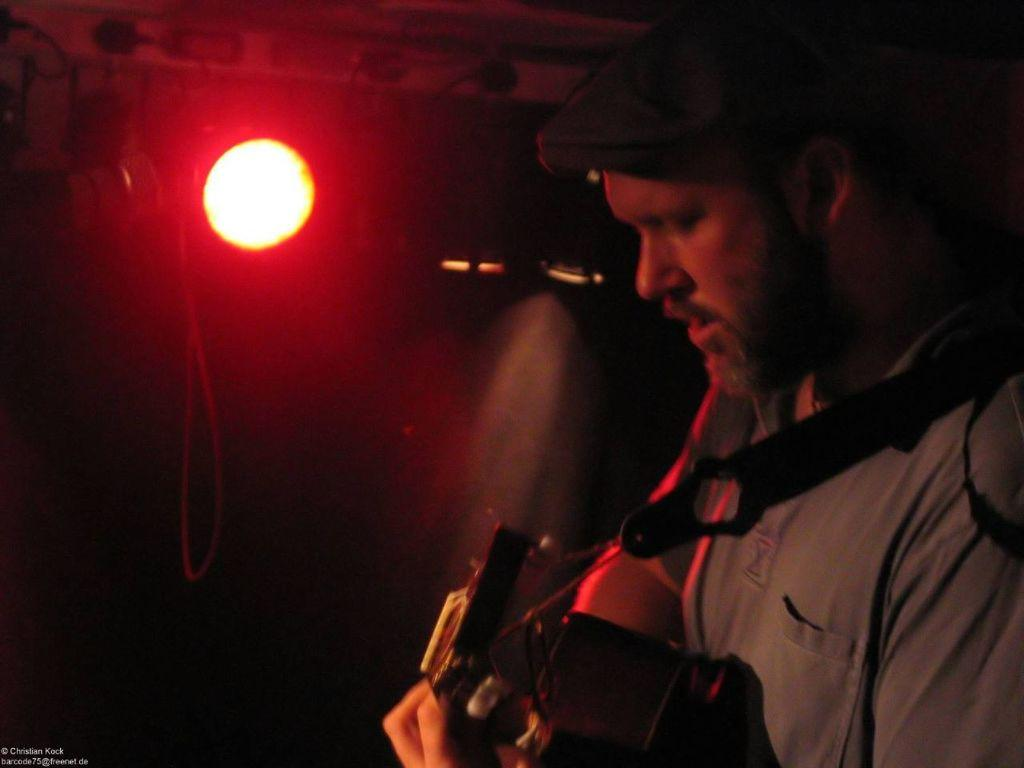What is the main subject of the image? There is a man in the image. What is the man doing in the image? The man is standing in the dark and playing the guitar. What object is the man holding in the image? The man is holding a guitar. What can be seen on the wall in the image? There is a focus light on the wall, and it is red in color. How does the man express his anger while playing the guitar in the image? The image does not show the man expressing anger or any other emotion while playing the guitar. Is the man sleeping in the image? No, the man is not sleeping in the image; he is standing and playing the guitar. 